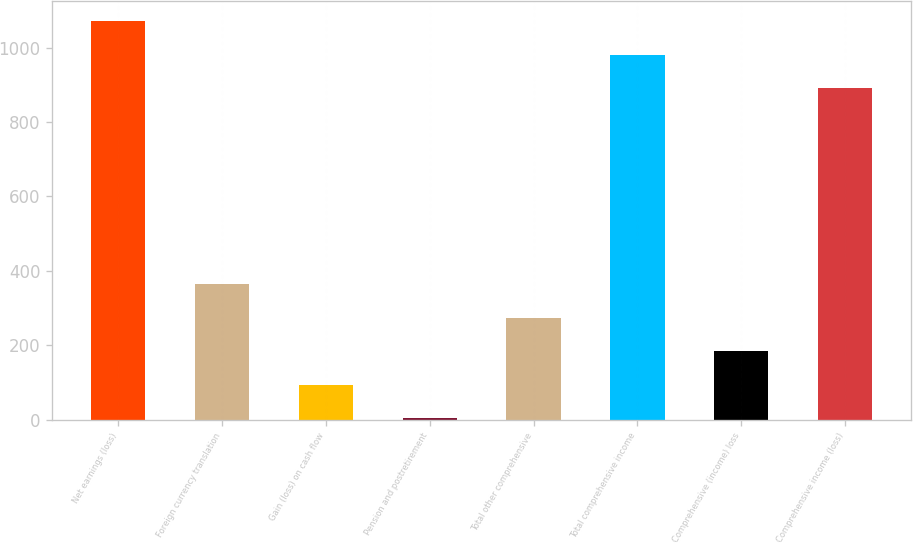Convert chart to OTSL. <chart><loc_0><loc_0><loc_500><loc_500><bar_chart><fcel>Net earnings (loss)<fcel>Foreign currency translation<fcel>Gain (loss) on cash flow<fcel>Pension and postretirement<fcel>Total other comprehensive<fcel>Total comprehensive income<fcel>Comprehensive (income) loss<fcel>Comprehensive income (loss)<nl><fcel>1070.4<fcel>364.8<fcel>94.2<fcel>4<fcel>274.6<fcel>980.2<fcel>184.4<fcel>890<nl></chart> 